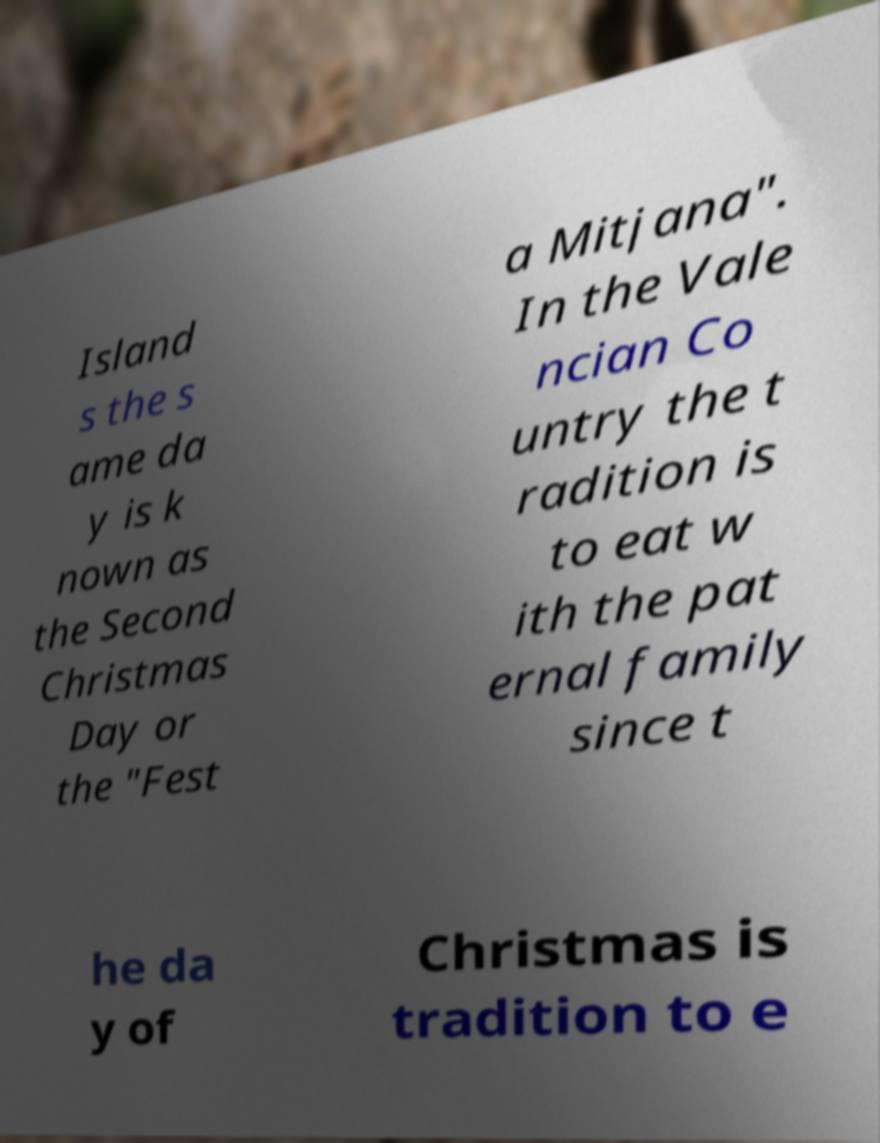Please read and relay the text visible in this image. What does it say? Island s the s ame da y is k nown as the Second Christmas Day or the "Fest a Mitjana". In the Vale ncian Co untry the t radition is to eat w ith the pat ernal family since t he da y of Christmas is tradition to e 